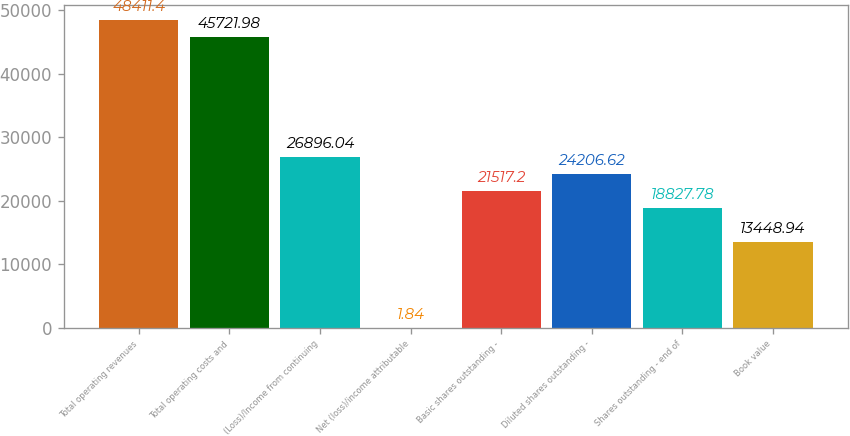Convert chart. <chart><loc_0><loc_0><loc_500><loc_500><bar_chart><fcel>Total operating revenues<fcel>Total operating costs and<fcel>(Loss)/Income from continuing<fcel>Net (loss)/income attributable<fcel>Basic shares outstanding -<fcel>Diluted shares outstanding -<fcel>Shares outstanding - end of<fcel>Book value<nl><fcel>48411.4<fcel>45722<fcel>26896<fcel>1.84<fcel>21517.2<fcel>24206.6<fcel>18827.8<fcel>13448.9<nl></chart> 